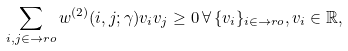<formula> <loc_0><loc_0><loc_500><loc_500>\sum _ { i , j \in \to r o } w ^ { ( 2 ) } ( i , j ; \gamma ) v _ { i } v _ { j } \geq 0 \, \forall \, \{ v _ { i } \} _ { i \in \to r o } , v _ { i } \in { \mathbb { R } } ,</formula> 